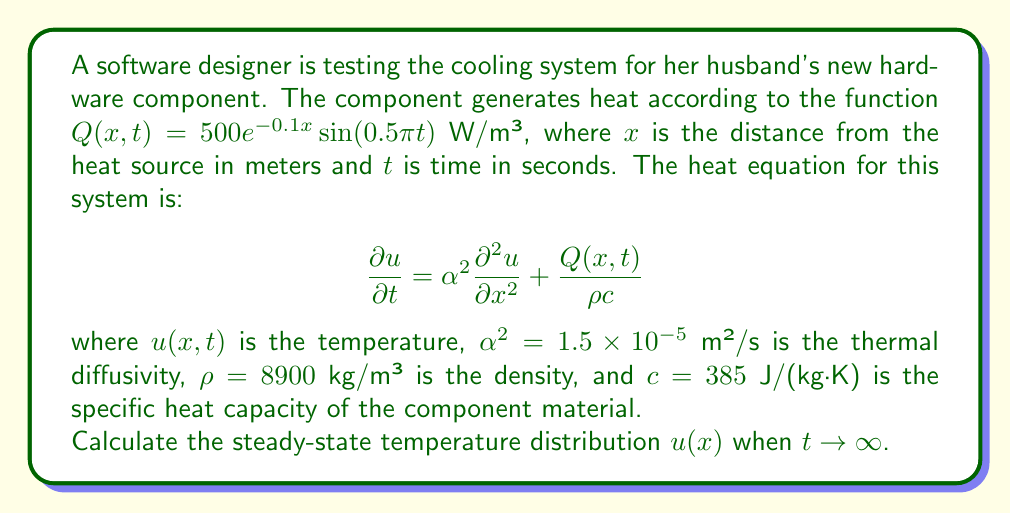Help me with this question. To solve this problem, we follow these steps:

1) For the steady-state solution, $\frac{\partial u}{\partial t} = 0$. Also, as $t \to \infty$, the time-dependent part of $Q(x,t)$ averages to zero. So, we use the time-averaged heat source:

   $Q_{avg}(x) = \frac{500e^{-0.1x}}{2}$ W/m³

2) The steady-state heat equation becomes:

   $$0 = \alpha^2 \frac{d^2 u}{dx^2} + \frac{Q_{avg}(x)}{ρc}$$

3) Rearranging:

   $$\frac{d^2 u}{dx^2} = -\frac{Q_{avg}(x)}{\alpha^2 ρc} = -\frac{500e^{-0.1x}}{2\alpha^2 ρc}$$

4) Integrate twice:

   $$\frac{du}{dx} = \frac{500}{2\alpha^2 ρc} \cdot \frac{1}{0.1}e^{-0.1x} + C_1$$

   $$u(x) = -\frac{500}{2\alpha^2 ρc} \cdot \frac{1}{0.1^2}e^{-0.1x} + C_1x + C_2$$

5) Apply boundary conditions. Assume $u(0) = T_0$ (ambient temperature) and $u(\infty) = T_0$:

   At $x = 0$: $T_0 = -\frac{500}{2\alpha^2 ρc} \cdot \frac{1}{0.1^2} + C_2$
   
   At $x \to \infty$: $T_0 = C_2$

6) Solve for constants:

   $C_2 = T_0$
   
   $C_1 = 0$

7) The final steady-state temperature distribution is:

   $$u(x) = T_0 + \frac{500}{2\alpha^2 ρc} \cdot \frac{1}{0.1^2}(1 - e^{-0.1x})$$

8) Substitute the given values:

   $$u(x) = T_0 + \frac{500}{2(1.5 \times 10^{-5})(8900)(385)} \cdot \frac{1}{0.1^2}(1 - e^{-0.1x})$$

   $$u(x) = T_0 + 48.19(1 - e^{-0.1x})$$
Answer: $u(x) = T_0 + 48.19(1 - e^{-0.1x})$ 